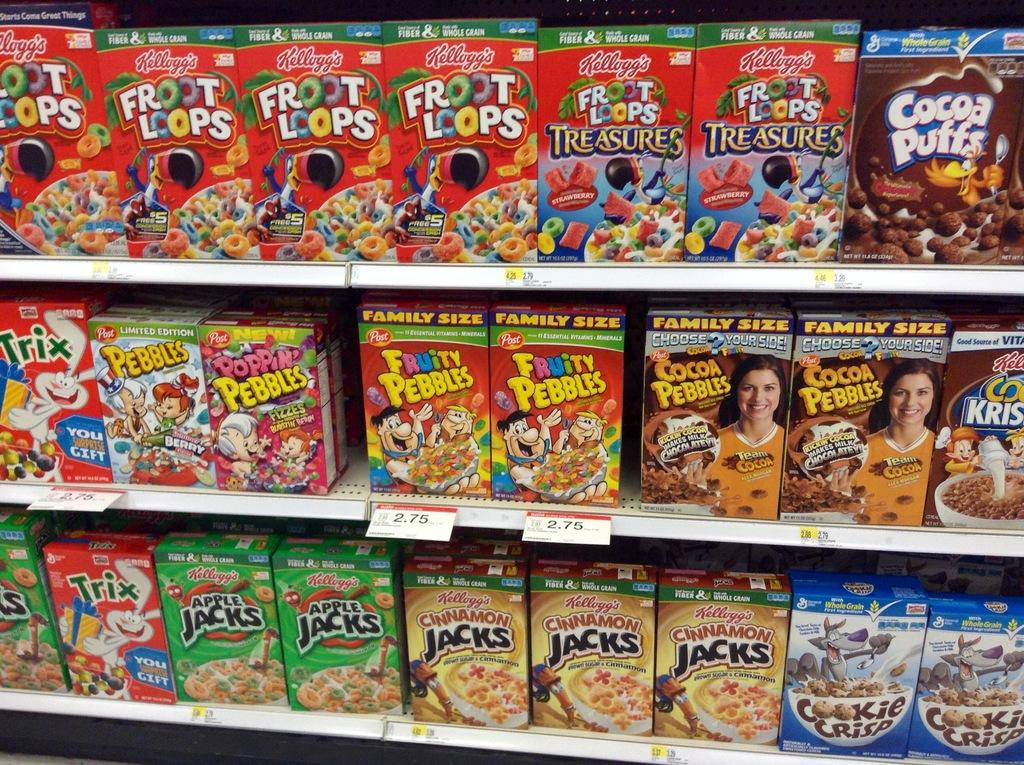<image>
Summarize the visual content of the image. A Fruity Pebbles box that is on a shelf with other cereals 